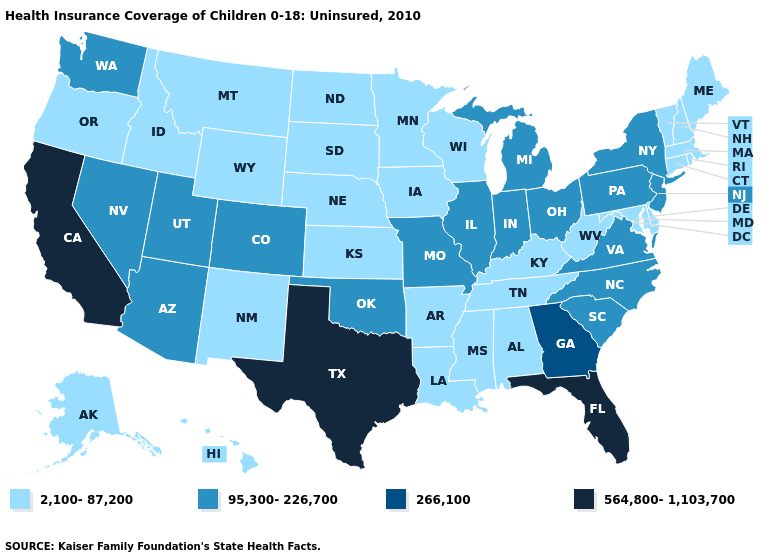What is the value of Pennsylvania?
Give a very brief answer. 95,300-226,700. What is the value of Kansas?
Give a very brief answer. 2,100-87,200. What is the value of Iowa?
Answer briefly. 2,100-87,200. Name the states that have a value in the range 95,300-226,700?
Keep it brief. Arizona, Colorado, Illinois, Indiana, Michigan, Missouri, Nevada, New Jersey, New York, North Carolina, Ohio, Oklahoma, Pennsylvania, South Carolina, Utah, Virginia, Washington. Among the states that border New Hampshire , which have the highest value?
Quick response, please. Maine, Massachusetts, Vermont. Name the states that have a value in the range 2,100-87,200?
Be succinct. Alabama, Alaska, Arkansas, Connecticut, Delaware, Hawaii, Idaho, Iowa, Kansas, Kentucky, Louisiana, Maine, Maryland, Massachusetts, Minnesota, Mississippi, Montana, Nebraska, New Hampshire, New Mexico, North Dakota, Oregon, Rhode Island, South Dakota, Tennessee, Vermont, West Virginia, Wisconsin, Wyoming. What is the value of Maryland?
Give a very brief answer. 2,100-87,200. Which states have the lowest value in the USA?
Keep it brief. Alabama, Alaska, Arkansas, Connecticut, Delaware, Hawaii, Idaho, Iowa, Kansas, Kentucky, Louisiana, Maine, Maryland, Massachusetts, Minnesota, Mississippi, Montana, Nebraska, New Hampshire, New Mexico, North Dakota, Oregon, Rhode Island, South Dakota, Tennessee, Vermont, West Virginia, Wisconsin, Wyoming. What is the value of Minnesota?
Be succinct. 2,100-87,200. Name the states that have a value in the range 564,800-1,103,700?
Short answer required. California, Florida, Texas. How many symbols are there in the legend?
Be succinct. 4. What is the value of Tennessee?
Write a very short answer. 2,100-87,200. Is the legend a continuous bar?
Concise answer only. No. Among the states that border Michigan , which have the lowest value?
Short answer required. Wisconsin. What is the value of Arkansas?
Short answer required. 2,100-87,200. 